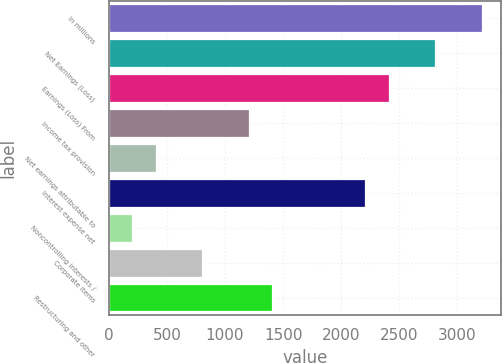Convert chart to OTSL. <chart><loc_0><loc_0><loc_500><loc_500><bar_chart><fcel>In millions<fcel>Net Earnings (Loss)<fcel>Earnings (Loss) From<fcel>Income tax provision<fcel>Net earnings attributable to<fcel>Interest expense net<fcel>Noncontrolling interests /<fcel>Corporate items<fcel>Restructuring and other<nl><fcel>3212.2<fcel>2810.8<fcel>2409.4<fcel>1205.2<fcel>402.4<fcel>2208.7<fcel>201.7<fcel>803.8<fcel>1405.9<nl></chart> 